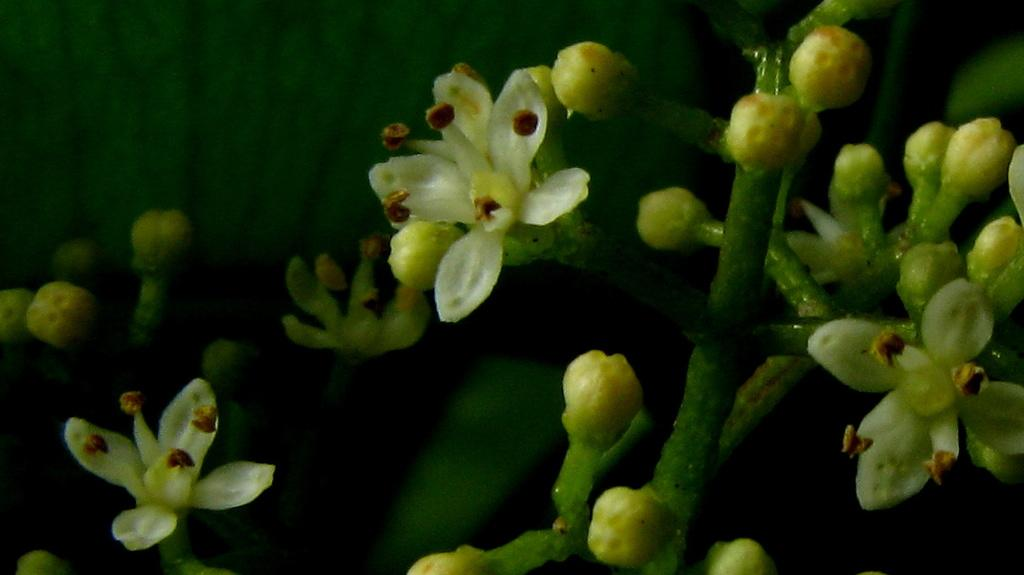What type of plants are in the image? There are flowers in the image. What stage of growth are the flowers in? There are buds on the stems of the flowers. What color is the background of the image? The background of the image is black. How many rabbits can be seen eating the cake in the image? There are no rabbits or cake present in the image; it features flowers with buds on their stems against a black background. 